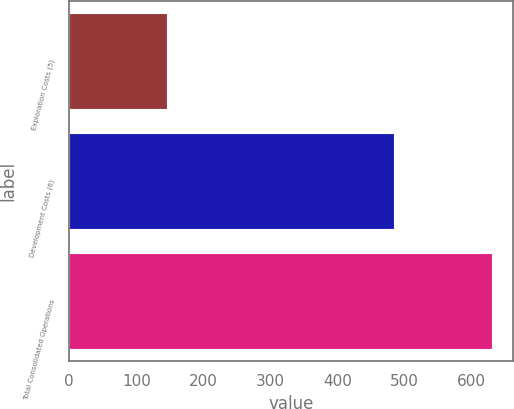Convert chart. <chart><loc_0><loc_0><loc_500><loc_500><bar_chart><fcel>Exploration Costs (5)<fcel>Development Costs (6)<fcel>Total Consolidated Operations<nl><fcel>146<fcel>485<fcel>631<nl></chart> 